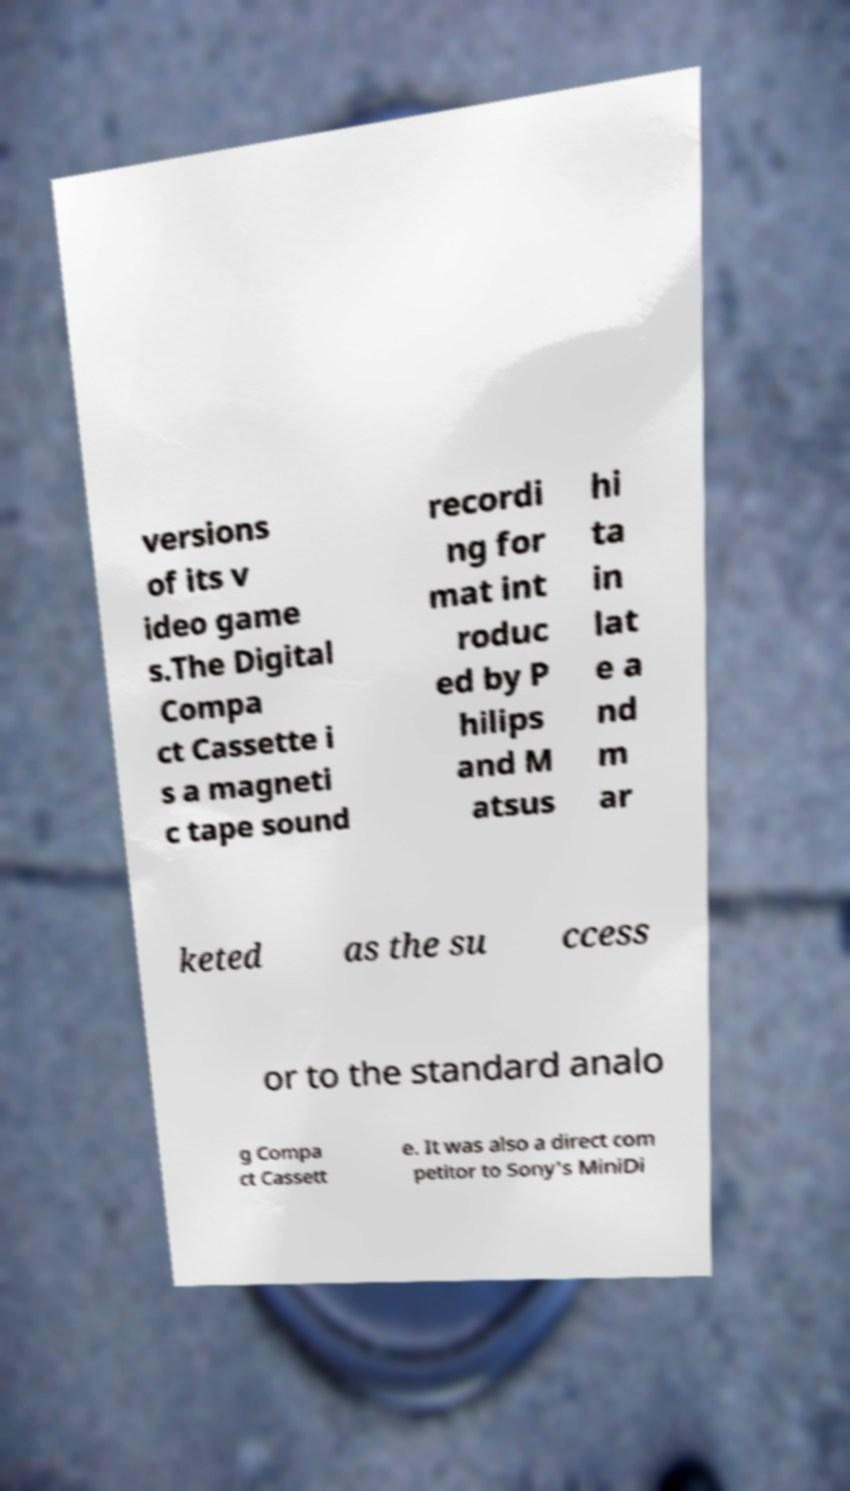I need the written content from this picture converted into text. Can you do that? versions of its v ideo game s.The Digital Compa ct Cassette i s a magneti c tape sound recordi ng for mat int roduc ed by P hilips and M atsus hi ta in lat e a nd m ar keted as the su ccess or to the standard analo g Compa ct Cassett e. It was also a direct com petitor to Sony's MiniDi 